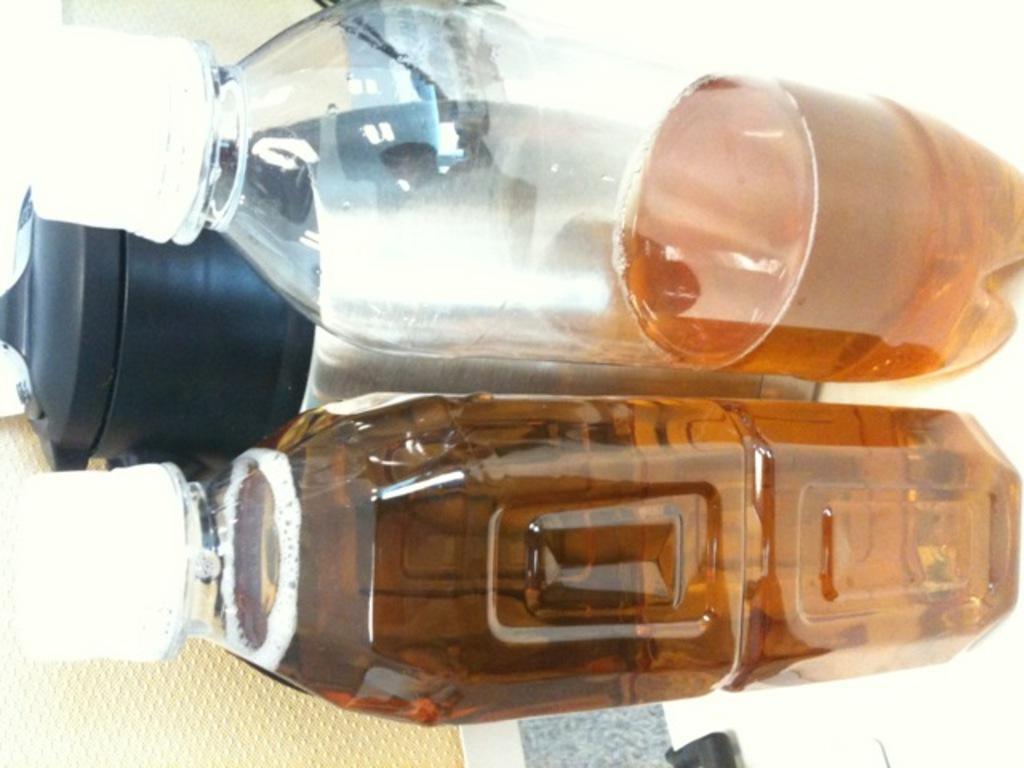In one or two sentences, can you explain what this image depicts? In this picture there are three bottles in the horizontal way, it contain different type of liquids in it in this picture. 